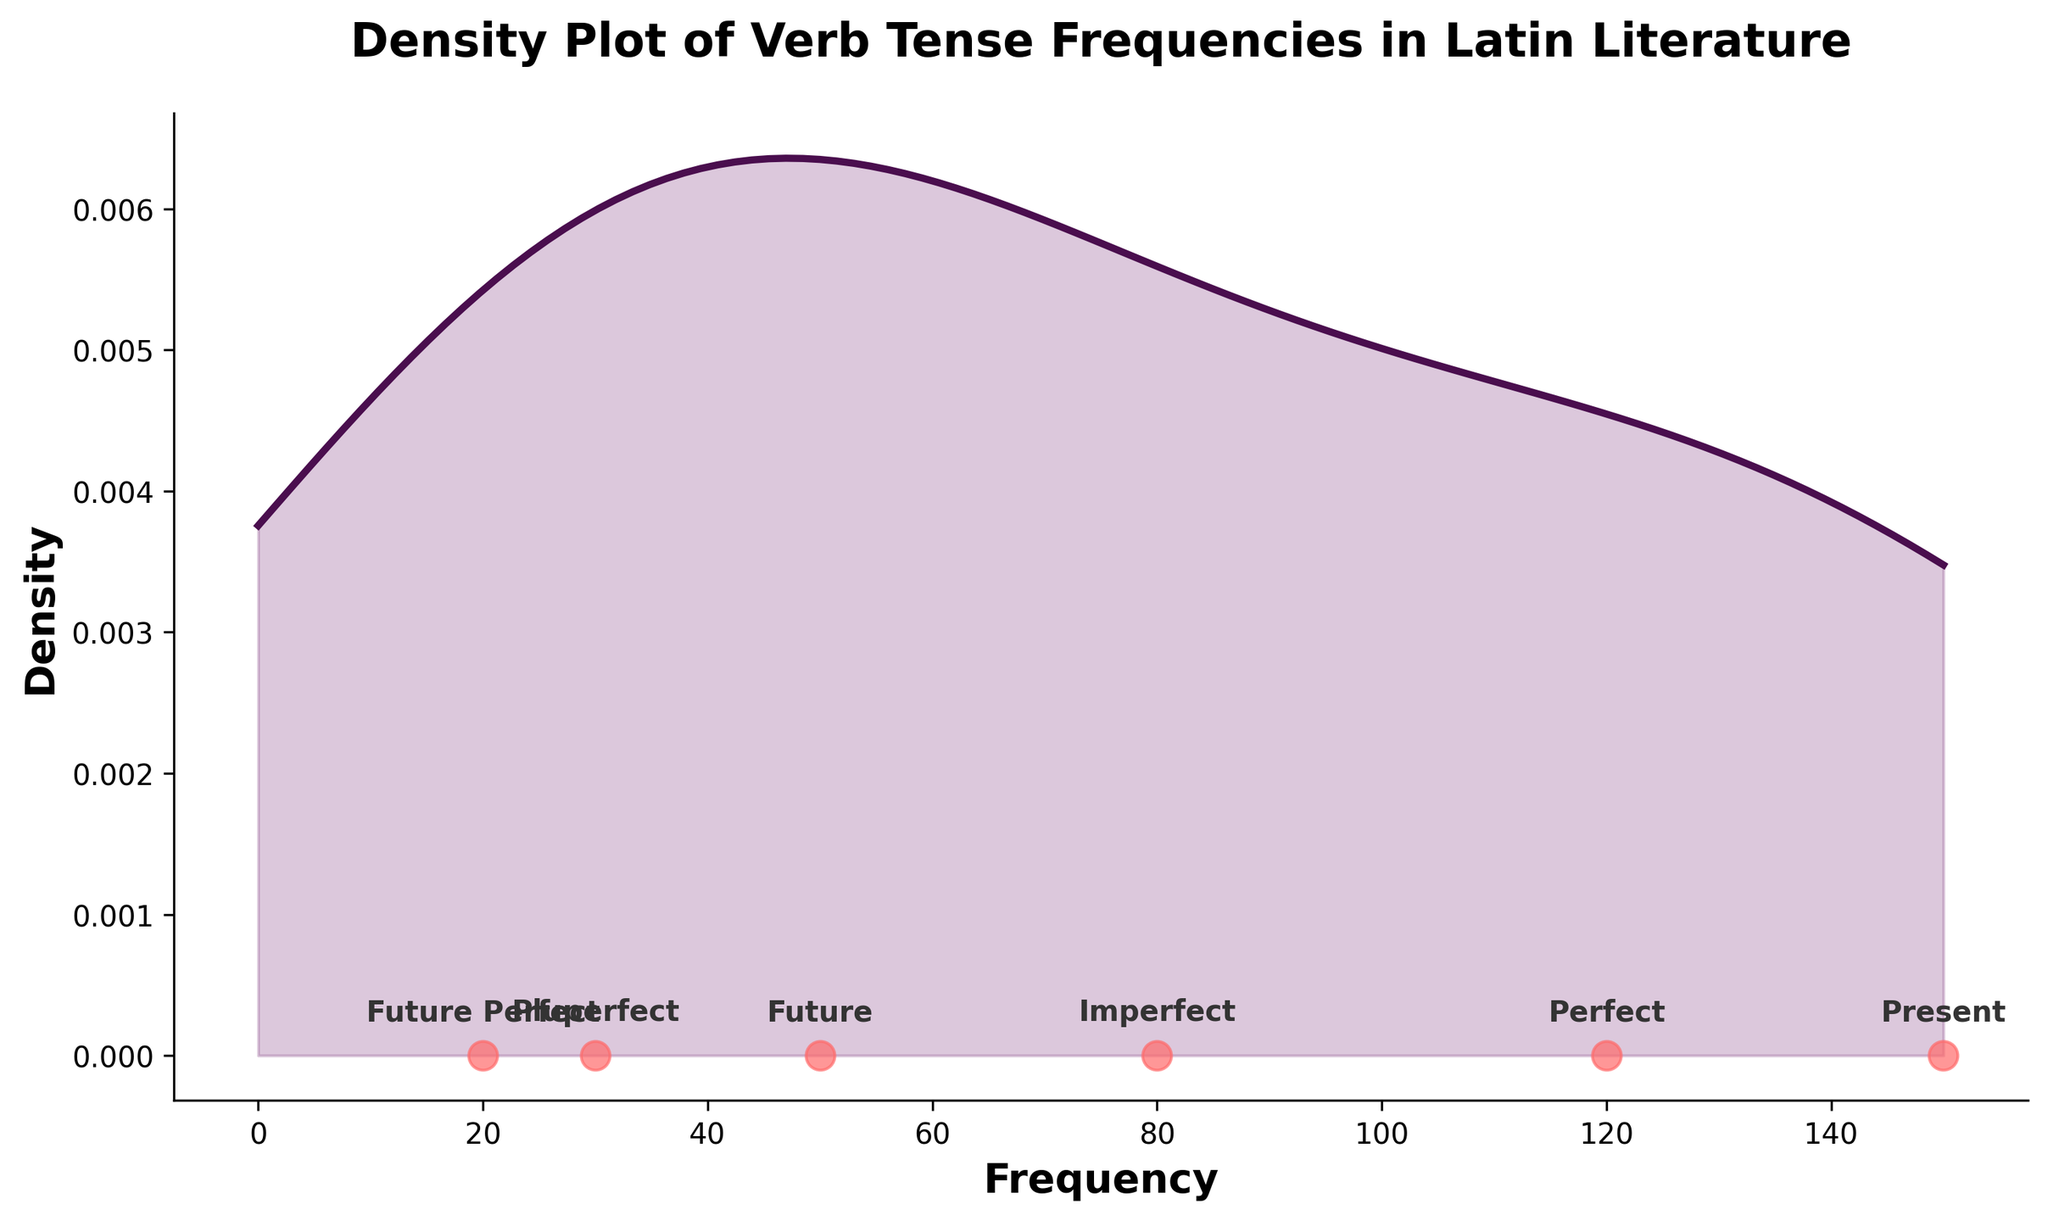How many verb tenses are represented in the plot? By counting the labels given to the data points along the x-axis in the plot, we can determine the number of unique verb tenses.
Answer: 6 What is the highest frequency of verb tense in the data? The highest frequency can be identified by looking at the rightmost data point on the x-axis, which corresponds to the present tense with a count of 150.
Answer: 150 What verb tense has the lowest frequency? The lowest frequency can be identified by finding the leftmost data point on the x-axis, which corresponds to the future perfect tense with a count of 20.
Answer: Future Perfect What is the total combined frequency of the Perfect and Pluperfect tenses? Look at the counts of the Perfect and Pluperfect tenses (120 and 30, respectively), and then sum them together: 120 + 30.
Answer: 150 Which verb tense has a frequency of 80? Find the data point that has the label corresponding to a count of 80, which is the Imperfect tense.
Answer: Imperfect By how much does the frequency of the Future tense differ from the Present tense? Identify the counts for the Future (50) and Present (150) tenses, then subtract the smaller count from the larger: 150 - 50.
Answer: 100 How is the density of verb tenses distributed around the frequency of 100? Observe the density curve around the x-value of 100; the curve's height indicates that the density is lower here compared to the peak around 50 and 150.
Answer: Lower Are there more verb tenses with frequencies below or above 80? Count the data points with frequencies below 80 (3: Pluperfect, Future, Future Perfect) and above 80 (2: Perfect, Present).
Answer: Below What is the range of the frequency values shown in the plot? Identify the minimum (20) and maximum (150) counts on the x-axis, and calculate the range: 150 - 20.
Answer: 130 Which two verb tenses have the smallest gap in their frequency counts? Compare the counts and differences between data points; the smallest gap is between the frequencies of Future (50) and Imperfect (80), with a gap of 30.
Answer: Future and Imperfect 